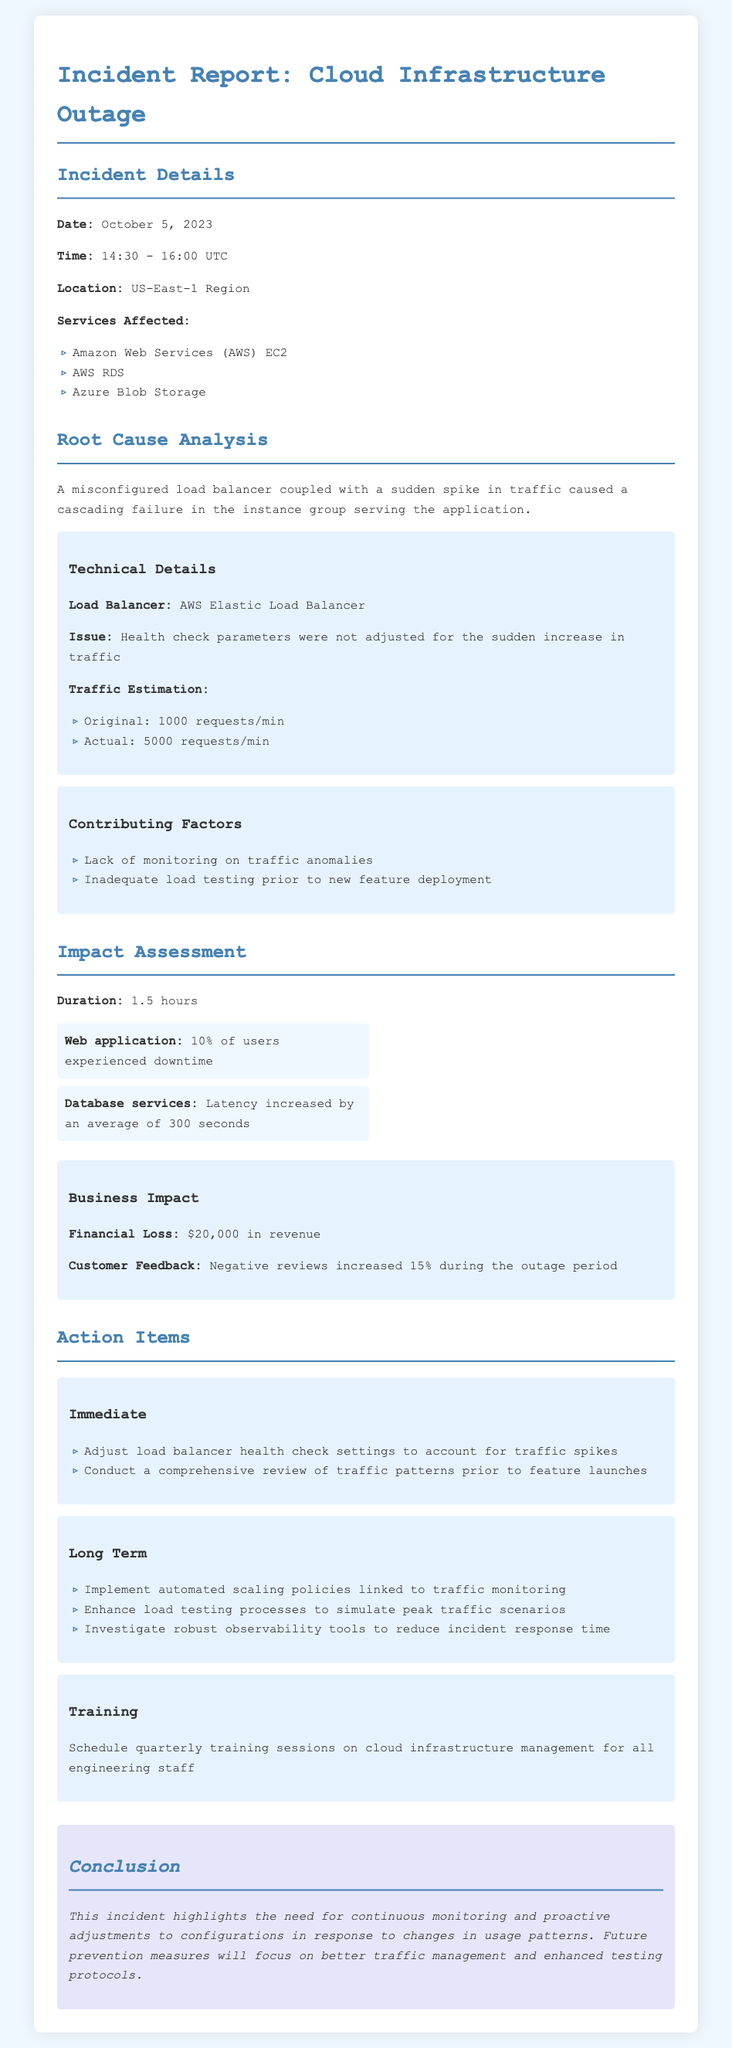what date did the incident occur? The incident occurred on October 5, 2023, as specified in the Incident Details section.
Answer: October 5, 2023 what services were affected? The affected services are listed under Services Affected, including AWS EC2, AWS RDS, and Azure Blob Storage.
Answer: AWS EC2, AWS RDS, Azure Blob Storage what caused the cascading failure? The root cause analysis explains that a misconfigured load balancer and sudden traffic spike caused a cascading failure.
Answer: Misconfigured load balancer and sudden traffic spike how many users experienced downtime? The impact assessment indicates that 10% of users experienced downtime during the incident.
Answer: 10% what was the financial loss? The document specifies the financial loss incurred during the incident was $20,000.
Answer: $20,000 what was the original traffic estimation? The original traffic estimation is listed in the technical details as 1000 requests per minute.
Answer: 1000 requests/min what is one immediate action item? The action items section includes immediate actions; one of them is adjusting load balancer health check settings.
Answer: Adjust load balancer health check settings why is continuous monitoring important? The conclusion notes that continuous monitoring is essential for proactive adjustments to configurations based on usage patterns.
Answer: Continuous monitoring is essential for proactive adjustments 